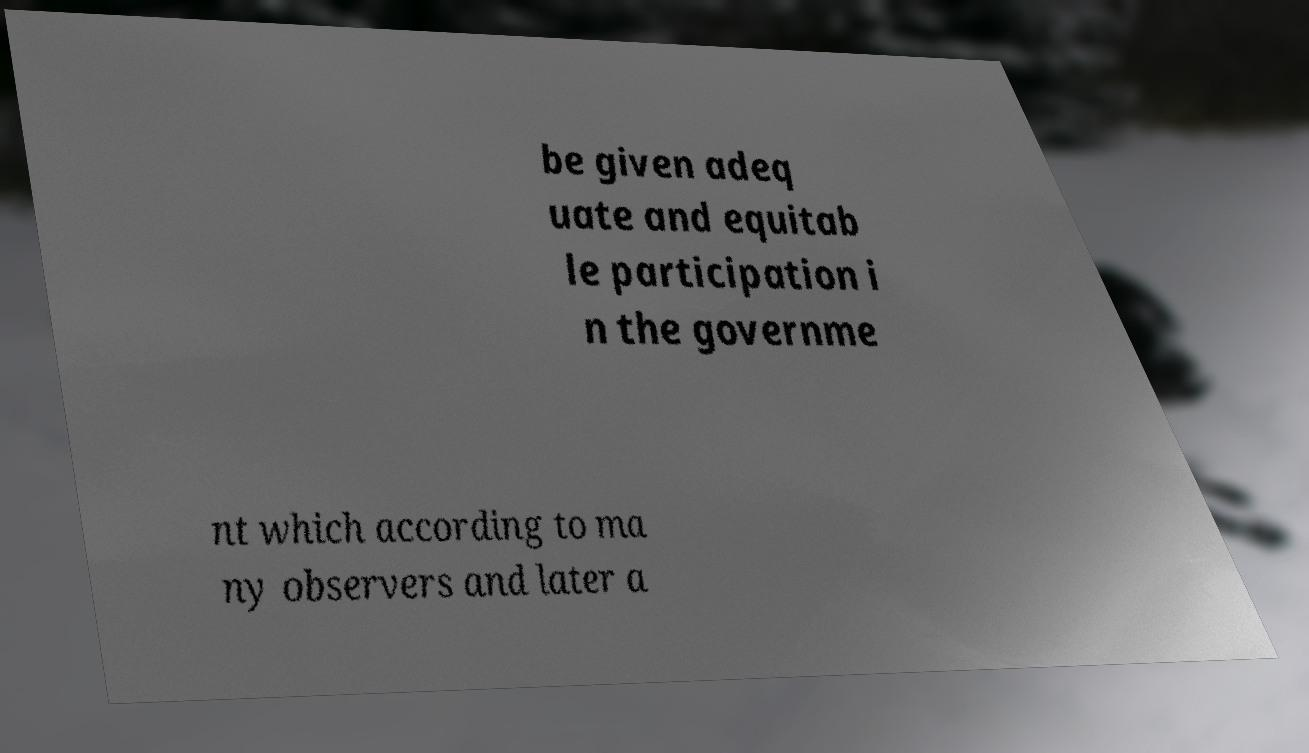Could you extract and type out the text from this image? be given adeq uate and equitab le participation i n the governme nt which according to ma ny observers and later a 